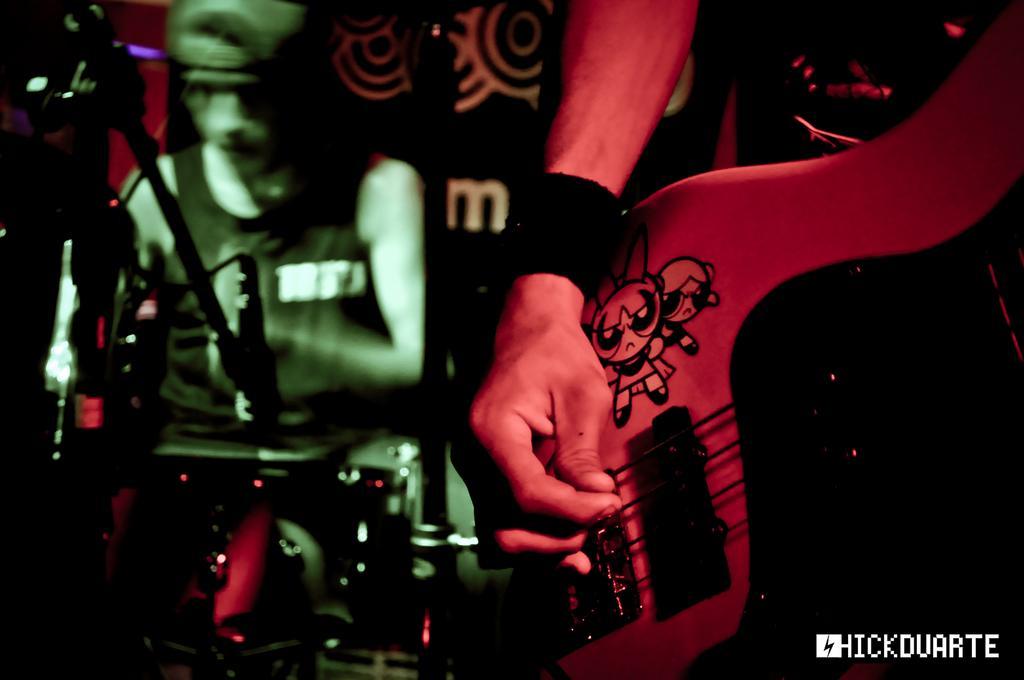Can you describe this image briefly? In this image, we can see few musical instruments. On the right, woman is holding a guitar. He is playing a music. On the left side, we can see stand, microphone. An another person is playing a musical instrument. And he wear a cap on his head. At the background, we can see banners. 